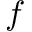<formula> <loc_0><loc_0><loc_500><loc_500>f</formula> 